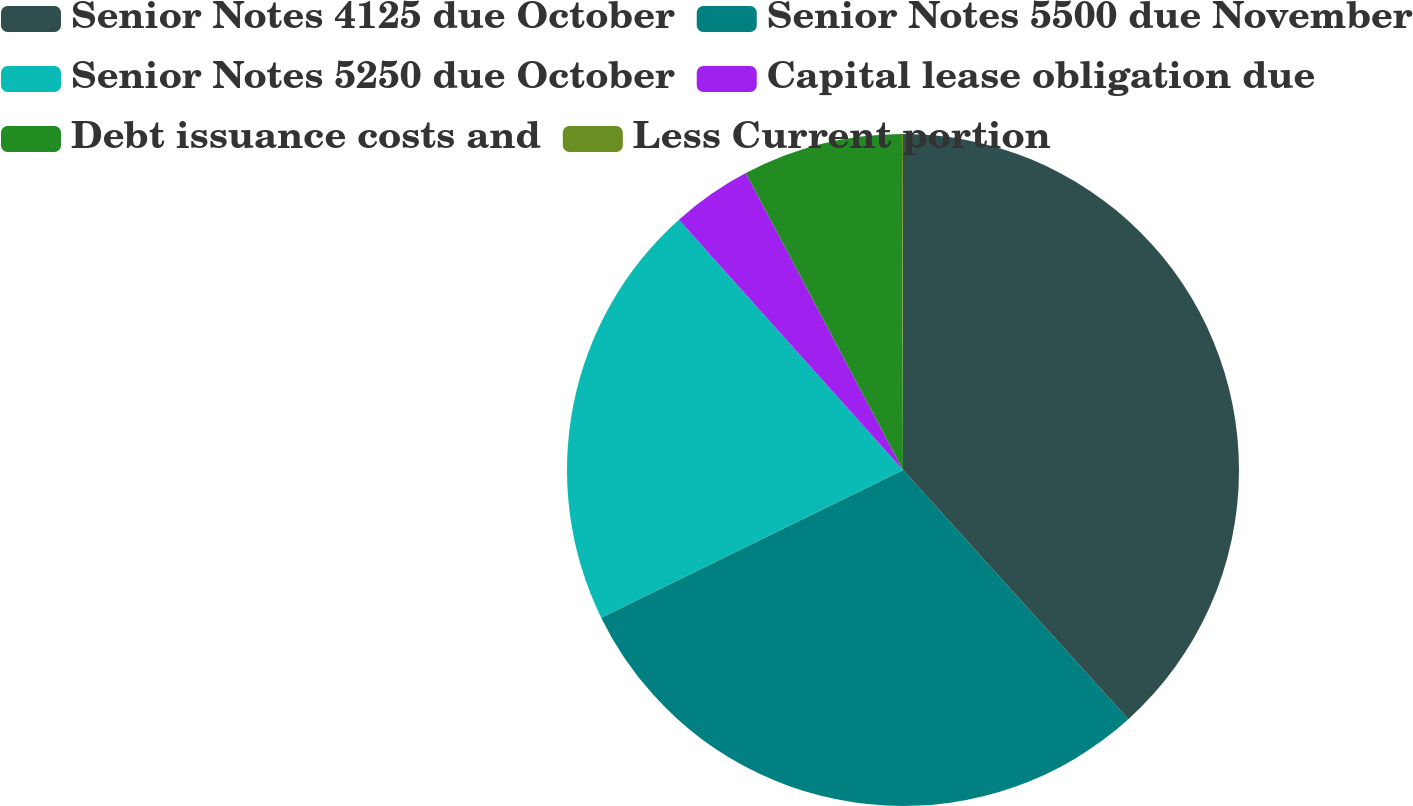Convert chart. <chart><loc_0><loc_0><loc_500><loc_500><pie_chart><fcel>Senior Notes 4125 due October<fcel>Senior Notes 5500 due November<fcel>Senior Notes 5250 due October<fcel>Capital lease obligation due<fcel>Debt issuance costs and<fcel>Less Current portion<nl><fcel>38.3%<fcel>29.46%<fcel>20.62%<fcel>3.87%<fcel>7.7%<fcel>0.05%<nl></chart> 